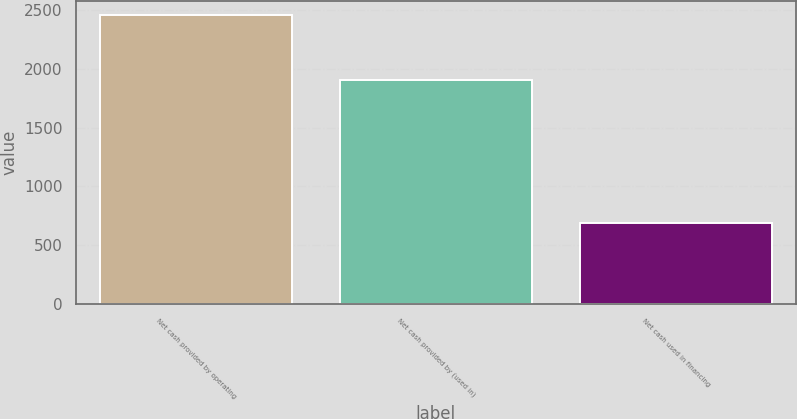Convert chart. <chart><loc_0><loc_0><loc_500><loc_500><bar_chart><fcel>Net cash provided by operating<fcel>Net cash provided by (used in)<fcel>Net cash used in financing<nl><fcel>2455<fcel>1900<fcel>687<nl></chart> 